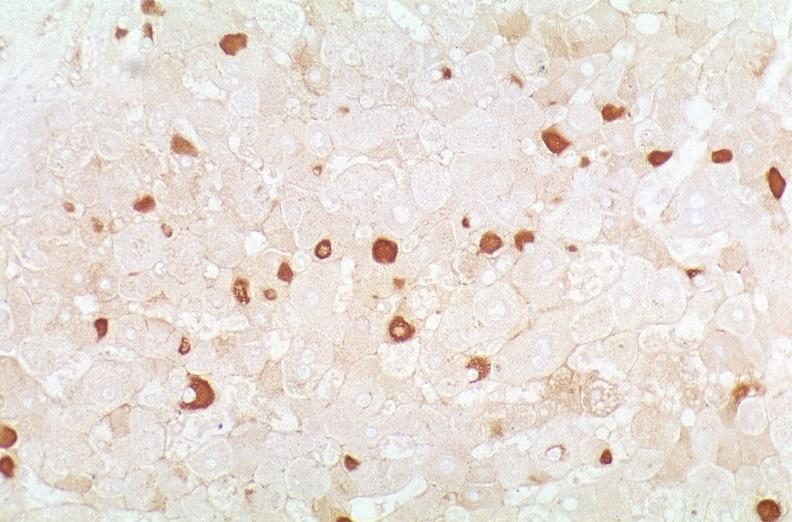does artery show hepatitis b virus, hepatocellular carcinoma?
Answer the question using a single word or phrase. No 